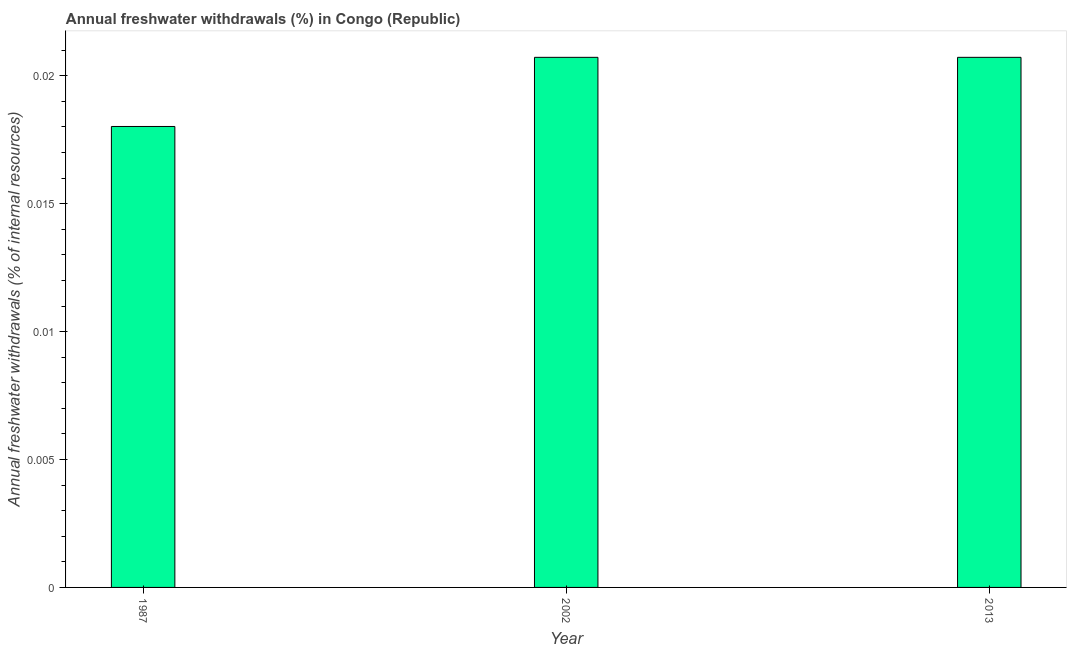What is the title of the graph?
Provide a short and direct response. Annual freshwater withdrawals (%) in Congo (Republic). What is the label or title of the X-axis?
Make the answer very short. Year. What is the label or title of the Y-axis?
Your answer should be compact. Annual freshwater withdrawals (% of internal resources). What is the annual freshwater withdrawals in 2002?
Keep it short and to the point. 0.02. Across all years, what is the maximum annual freshwater withdrawals?
Give a very brief answer. 0.02. Across all years, what is the minimum annual freshwater withdrawals?
Offer a very short reply. 0.02. In which year was the annual freshwater withdrawals minimum?
Keep it short and to the point. 1987. What is the sum of the annual freshwater withdrawals?
Your response must be concise. 0.06. What is the difference between the annual freshwater withdrawals in 1987 and 2013?
Your answer should be very brief. -0. What is the median annual freshwater withdrawals?
Ensure brevity in your answer.  0.02. In how many years, is the annual freshwater withdrawals greater than 0.017 %?
Provide a succinct answer. 3. Do a majority of the years between 2002 and 1987 (inclusive) have annual freshwater withdrawals greater than 0.007 %?
Offer a terse response. No. What is the ratio of the annual freshwater withdrawals in 1987 to that in 2013?
Offer a terse response. 0.87. Is the sum of the annual freshwater withdrawals in 1987 and 2002 greater than the maximum annual freshwater withdrawals across all years?
Provide a short and direct response. Yes. What is the difference between the highest and the lowest annual freshwater withdrawals?
Ensure brevity in your answer.  0. In how many years, is the annual freshwater withdrawals greater than the average annual freshwater withdrawals taken over all years?
Your response must be concise. 2. How many bars are there?
Your answer should be compact. 3. How many years are there in the graph?
Your response must be concise. 3. What is the difference between two consecutive major ticks on the Y-axis?
Keep it short and to the point. 0.01. Are the values on the major ticks of Y-axis written in scientific E-notation?
Offer a very short reply. No. What is the Annual freshwater withdrawals (% of internal resources) in 1987?
Make the answer very short. 0.02. What is the Annual freshwater withdrawals (% of internal resources) in 2002?
Provide a succinct answer. 0.02. What is the Annual freshwater withdrawals (% of internal resources) of 2013?
Provide a short and direct response. 0.02. What is the difference between the Annual freshwater withdrawals (% of internal resources) in 1987 and 2002?
Provide a succinct answer. -0. What is the difference between the Annual freshwater withdrawals (% of internal resources) in 1987 and 2013?
Offer a very short reply. -0. What is the ratio of the Annual freshwater withdrawals (% of internal resources) in 1987 to that in 2002?
Offer a terse response. 0.87. What is the ratio of the Annual freshwater withdrawals (% of internal resources) in 1987 to that in 2013?
Keep it short and to the point. 0.87. 